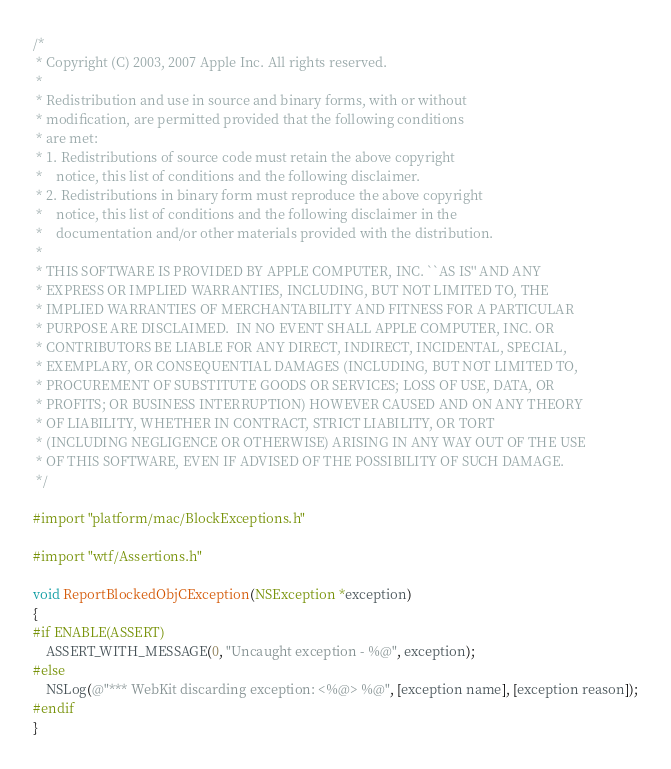<code> <loc_0><loc_0><loc_500><loc_500><_ObjectiveC_>/*
 * Copyright (C) 2003, 2007 Apple Inc. All rights reserved.
 *
 * Redistribution and use in source and binary forms, with or without
 * modification, are permitted provided that the following conditions
 * are met:
 * 1. Redistributions of source code must retain the above copyright
 *    notice, this list of conditions and the following disclaimer.
 * 2. Redistributions in binary form must reproduce the above copyright
 *    notice, this list of conditions and the following disclaimer in the
 *    documentation and/or other materials provided with the distribution.
 *
 * THIS SOFTWARE IS PROVIDED BY APPLE COMPUTER, INC. ``AS IS'' AND ANY
 * EXPRESS OR IMPLIED WARRANTIES, INCLUDING, BUT NOT LIMITED TO, THE
 * IMPLIED WARRANTIES OF MERCHANTABILITY AND FITNESS FOR A PARTICULAR
 * PURPOSE ARE DISCLAIMED.  IN NO EVENT SHALL APPLE COMPUTER, INC. OR
 * CONTRIBUTORS BE LIABLE FOR ANY DIRECT, INDIRECT, INCIDENTAL, SPECIAL,
 * EXEMPLARY, OR CONSEQUENTIAL DAMAGES (INCLUDING, BUT NOT LIMITED TO,
 * PROCUREMENT OF SUBSTITUTE GOODS OR SERVICES; LOSS OF USE, DATA, OR
 * PROFITS; OR BUSINESS INTERRUPTION) HOWEVER CAUSED AND ON ANY THEORY
 * OF LIABILITY, WHETHER IN CONTRACT, STRICT LIABILITY, OR TORT
 * (INCLUDING NEGLIGENCE OR OTHERWISE) ARISING IN ANY WAY OUT OF THE USE
 * OF THIS SOFTWARE, EVEN IF ADVISED OF THE POSSIBILITY OF SUCH DAMAGE. 
 */

#import "platform/mac/BlockExceptions.h"

#import "wtf/Assertions.h"

void ReportBlockedObjCException(NSException *exception)
{
#if ENABLE(ASSERT)
    ASSERT_WITH_MESSAGE(0, "Uncaught exception - %@", exception);
#else
    NSLog(@"*** WebKit discarding exception: <%@> %@", [exception name], [exception reason]);
#endif
}
</code> 